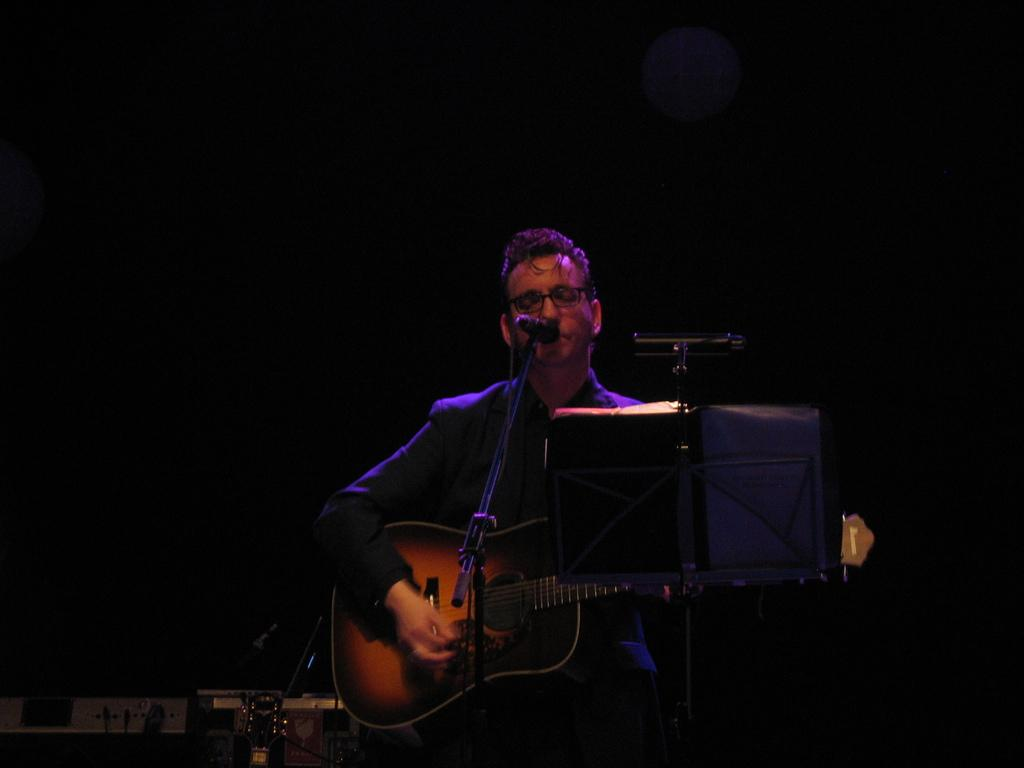What is the main subject of the image? The main subject of the image is a man. What is the man doing in the image? The man is standing and holding a guitar. What is the man near in the image? The man is near a microphone. What is the man wearing in the image? The man is wearing a blazer. What can be seen in the background of the image? There are musical instruments in the background, and the background is dark. Can you see a dog sleeping on the bed in the image? There is no dog or bed present in the image. 